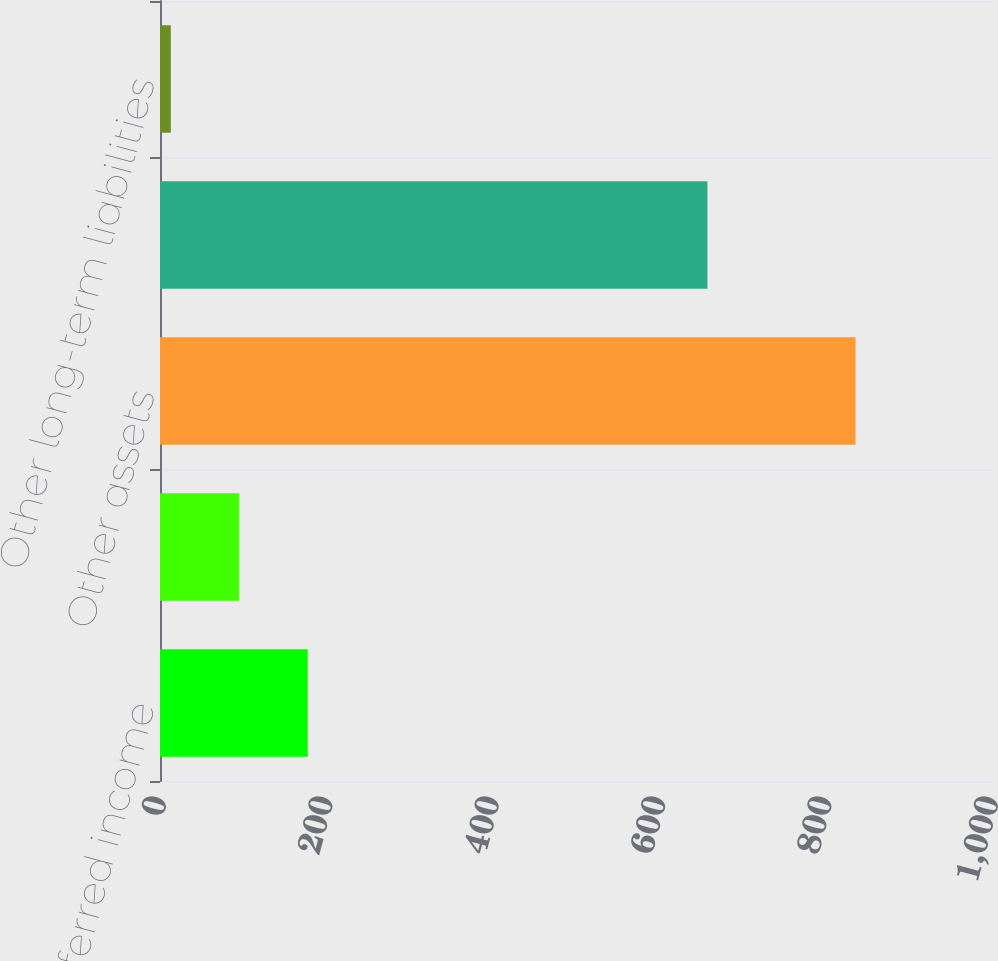Convert chart to OTSL. <chart><loc_0><loc_0><loc_500><loc_500><bar_chart><fcel>Short-term deferred income<fcel>Prepaid expense and other<fcel>Other assets<fcel>Accounts payable and accrued<fcel>Other long-term liabilities<nl><fcel>177.6<fcel>95.3<fcel>836<fcel>658<fcel>13<nl></chart> 